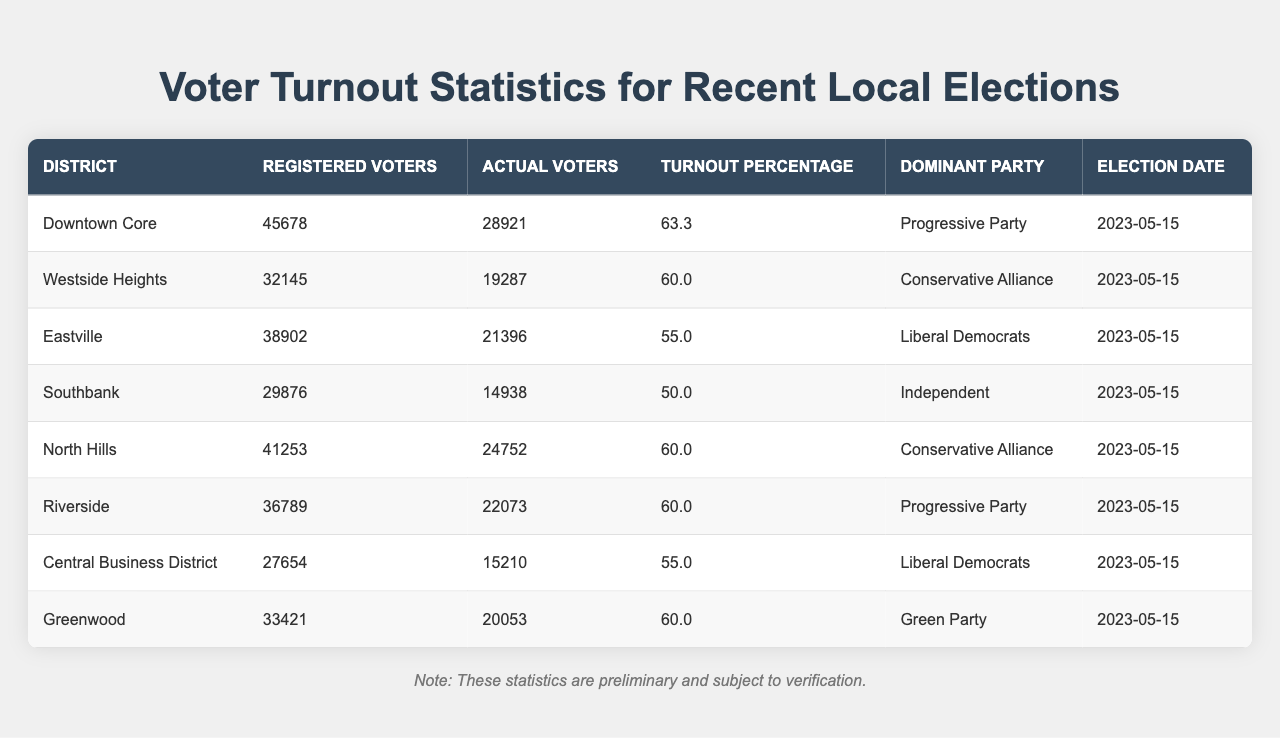What is the turnout percentage for the Downtown Core district? The table indicates that the turnout percentage for the Downtown Core is listed under the "Turnout Percentage" column, which shows 63.3%.
Answer: 63.3% How many actual voters participated in the Westside Heights elections? The actual voters for Westside Heights are provided in the "Actual Voters" column, where it states that 19287 individuals voted.
Answer: 19287 Which district had the lowest turnout percentage? By comparing the "Turnout Percentage" values across all districts, Southbank has the lowest at 50.0%.
Answer: Southbank What is the total number of registered voters across all districts? To find this total, we add the "Registered Voters" for each district: 45678 + 32145 + 38902 + 29876 + 41253 + 36789 + 27654 + 33421 =  2,228,362.
Answer: 228362 Did Riverside have a higher turnout percentage than Eastville? Riverside shows a turnout of 60.0%, while Eastville has a turnout of 55.0%. Since 60.0% is greater than 55.0%, Riverside did have a higher turnout percentage.
Answer: Yes What is the average turnout percentage of all districts? We calculate the average by summing the turnout percentages and dividing by the number of districts: (63.3 + 60.0 + 55.0 + 50.0 + 60.0 + 60.0 + 55.0 + 60.0) / 8 = 57.3%.
Answer: 57.3% In which district did the Liberal Democrats emerge as the dominant party? The table shows that Liberal Democrats are the dominant party in Eastville and Central Business District as mentioned in the "Dominant Party" column.
Answer: Eastville and Central Business District How many more registered voters are there in Downtown Core compared to Southbank? We subtract the registered voters of Southbank (29876) from Downtown Core (45678): 45678 - 29876 = 15702.
Answer: 15702 Is there any district with a turnout percentage of exactly 60.0%? Yes, looking at the "Turnout Percentage" column, both Westside Heights, North Hills, and Greenwood have a turnout percentage of 60.0%.
Answer: Yes What was the date of the elections for all districts? The "Election Date" column shows that all districts held their elections on May 15, 2023.
Answer: May 15, 2023 